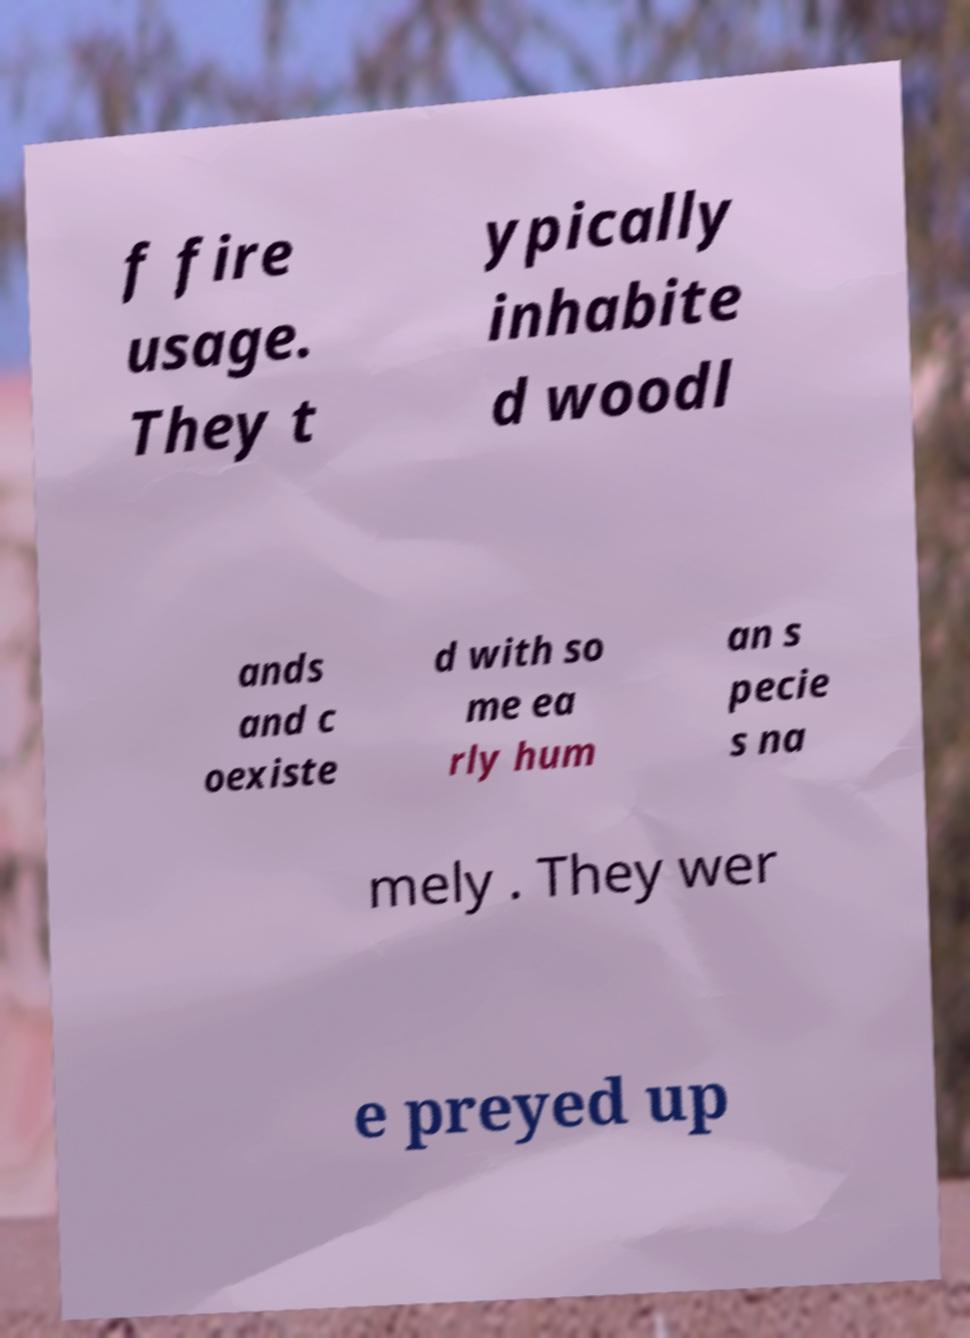What messages or text are displayed in this image? I need them in a readable, typed format. f fire usage. They t ypically inhabite d woodl ands and c oexiste d with so me ea rly hum an s pecie s na mely . They wer e preyed up 